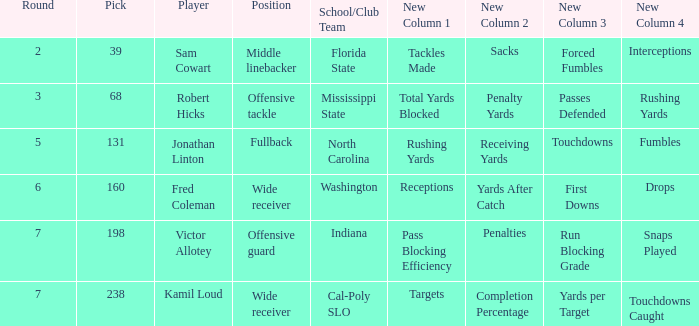Which Player has a Round smaller than 5, and a School/Club Team of florida state? Sam Cowart. Would you be able to parse every entry in this table? {'header': ['Round', 'Pick', 'Player', 'Position', 'School/Club Team', 'New Column 1', 'New Column 2', 'New Column 3', 'New Column 4'], 'rows': [['2', '39', 'Sam Cowart', 'Middle linebacker', 'Florida State', 'Tackles Made', 'Sacks', 'Forced Fumbles', 'Interceptions'], ['3', '68', 'Robert Hicks', 'Offensive tackle', 'Mississippi State', 'Total Yards Blocked', 'Penalty Yards', 'Passes Defended', 'Rushing Yards'], ['5', '131', 'Jonathan Linton', 'Fullback', 'North Carolina', 'Rushing Yards', 'Receiving Yards', 'Touchdowns', 'Fumbles'], ['6', '160', 'Fred Coleman', 'Wide receiver', 'Washington', 'Receptions', 'Yards After Catch', 'First Downs', 'Drops'], ['7', '198', 'Victor Allotey', 'Offensive guard', 'Indiana', 'Pass Blocking Efficiency', 'Penalties', 'Run Blocking Grade', 'Snaps Played'], ['7', '238', 'Kamil Loud', 'Wide receiver', 'Cal-Poly SLO', 'Targets', 'Completion Percentage', 'Yards per Target', 'Touchdowns Caught']]} 